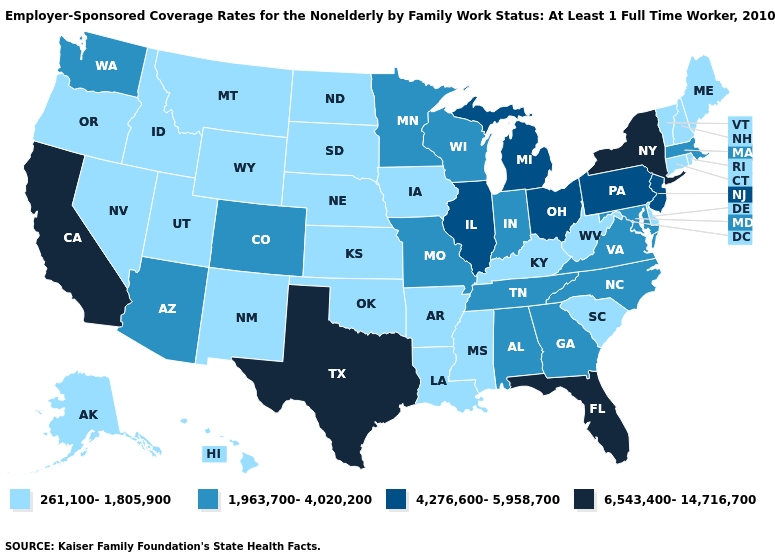Among the states that border New Jersey , which have the lowest value?
Quick response, please. Delaware. Name the states that have a value in the range 6,543,400-14,716,700?
Answer briefly. California, Florida, New York, Texas. What is the highest value in the USA?
Answer briefly. 6,543,400-14,716,700. Name the states that have a value in the range 6,543,400-14,716,700?
Keep it brief. California, Florida, New York, Texas. Does Oklahoma have the lowest value in the USA?
Short answer required. Yes. What is the value of Connecticut?
Answer briefly. 261,100-1,805,900. What is the value of Nevada?
Be succinct. 261,100-1,805,900. Which states have the lowest value in the Northeast?
Write a very short answer. Connecticut, Maine, New Hampshire, Rhode Island, Vermont. Does Rhode Island have a lower value than Michigan?
Give a very brief answer. Yes. What is the value of North Dakota?
Answer briefly. 261,100-1,805,900. Does California have a higher value than Maine?
Answer briefly. Yes. Name the states that have a value in the range 4,276,600-5,958,700?
Quick response, please. Illinois, Michigan, New Jersey, Ohio, Pennsylvania. What is the value of New Jersey?
Concise answer only. 4,276,600-5,958,700. Does Missouri have the lowest value in the MidWest?
Quick response, please. No. 